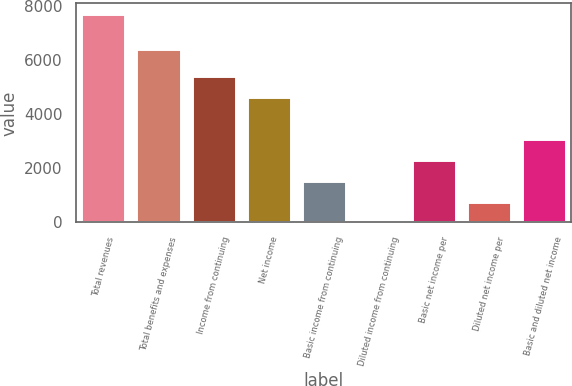Convert chart. <chart><loc_0><loc_0><loc_500><loc_500><bar_chart><fcel>Total revenues<fcel>Total benefits and expenses<fcel>Income from continuing<fcel>Net income<fcel>Basic income from continuing<fcel>Diluted income from continuing<fcel>Basic net income per<fcel>Diluted net income per<fcel>Basic and diluted net income<nl><fcel>7721<fcel>6403<fcel>5405.14<fcel>4633.19<fcel>1545.39<fcel>1.49<fcel>2317.34<fcel>773.44<fcel>3089.29<nl></chart> 